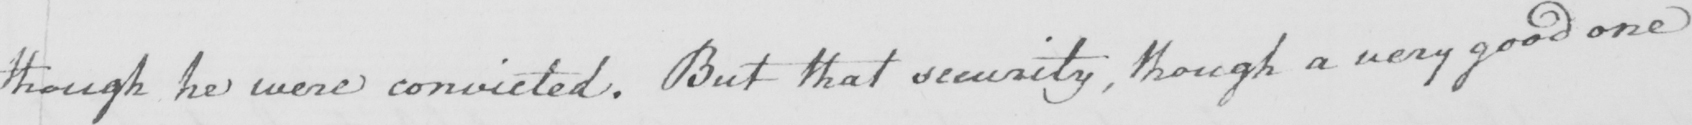Please transcribe the handwritten text in this image. though he were convicted . But that security  , though a very good one 